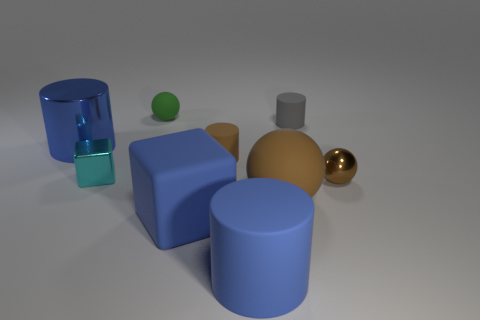What is the shape of the matte object that is the same color as the large rubber sphere?
Offer a terse response. Cylinder. There is a big blue matte object on the right side of the tiny brown thing that is on the left side of the large brown thing; what shape is it?
Ensure brevity in your answer.  Cylinder. What is the material of the large blue thing that is the same shape as the cyan thing?
Provide a short and direct response. Rubber. What color is the rubber cube that is the same size as the metallic cylinder?
Make the answer very short. Blue. Is the number of matte spheres that are left of the brown rubber ball the same as the number of small matte objects?
Give a very brief answer. No. There is a cylinder in front of the matte ball to the right of the tiny rubber ball; what is its color?
Your answer should be very brief. Blue. What size is the metallic thing that is to the left of the cube left of the green matte object?
Ensure brevity in your answer.  Large. What size is the other ball that is the same color as the big ball?
Provide a short and direct response. Small. What number of other things are there of the same size as the shiny ball?
Your answer should be compact. 4. There is a rubber ball on the right side of the blue cylinder in front of the large blue object to the left of the small green thing; what color is it?
Offer a very short reply. Brown. 